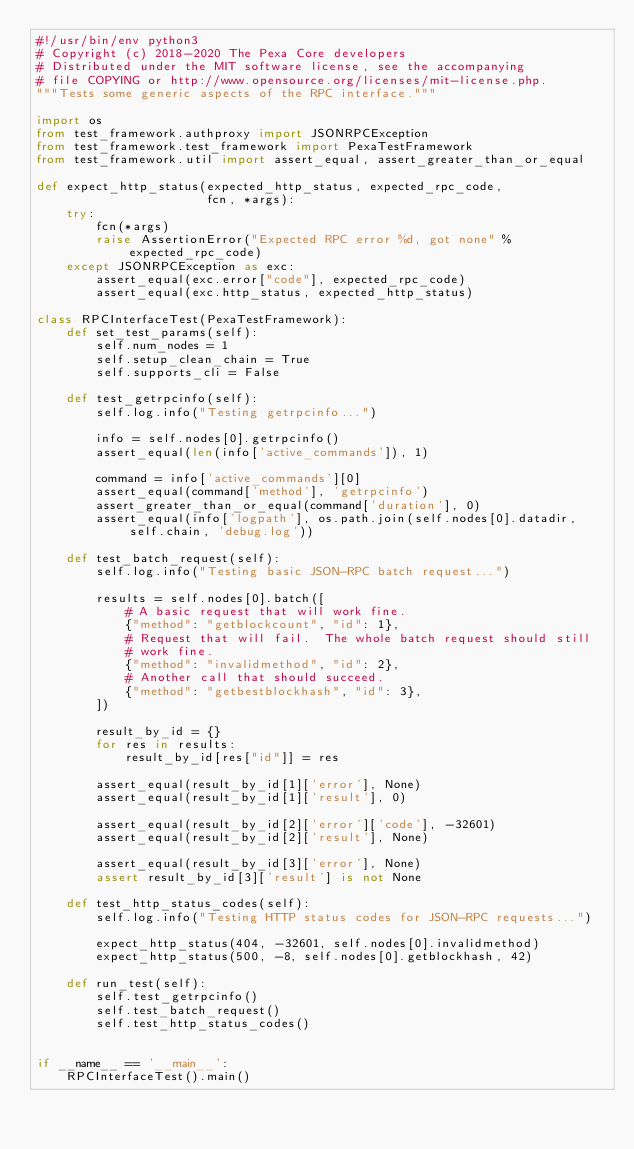<code> <loc_0><loc_0><loc_500><loc_500><_Python_>#!/usr/bin/env python3
# Copyright (c) 2018-2020 The Pexa Core developers
# Distributed under the MIT software license, see the accompanying
# file COPYING or http://www.opensource.org/licenses/mit-license.php.
"""Tests some generic aspects of the RPC interface."""

import os
from test_framework.authproxy import JSONRPCException
from test_framework.test_framework import PexaTestFramework
from test_framework.util import assert_equal, assert_greater_than_or_equal

def expect_http_status(expected_http_status, expected_rpc_code,
                       fcn, *args):
    try:
        fcn(*args)
        raise AssertionError("Expected RPC error %d, got none" % expected_rpc_code)
    except JSONRPCException as exc:
        assert_equal(exc.error["code"], expected_rpc_code)
        assert_equal(exc.http_status, expected_http_status)

class RPCInterfaceTest(PexaTestFramework):
    def set_test_params(self):
        self.num_nodes = 1
        self.setup_clean_chain = True
        self.supports_cli = False

    def test_getrpcinfo(self):
        self.log.info("Testing getrpcinfo...")

        info = self.nodes[0].getrpcinfo()
        assert_equal(len(info['active_commands']), 1)

        command = info['active_commands'][0]
        assert_equal(command['method'], 'getrpcinfo')
        assert_greater_than_or_equal(command['duration'], 0)
        assert_equal(info['logpath'], os.path.join(self.nodes[0].datadir, self.chain, 'debug.log'))

    def test_batch_request(self):
        self.log.info("Testing basic JSON-RPC batch request...")

        results = self.nodes[0].batch([
            # A basic request that will work fine.
            {"method": "getblockcount", "id": 1},
            # Request that will fail.  The whole batch request should still
            # work fine.
            {"method": "invalidmethod", "id": 2},
            # Another call that should succeed.
            {"method": "getbestblockhash", "id": 3},
        ])

        result_by_id = {}
        for res in results:
            result_by_id[res["id"]] = res

        assert_equal(result_by_id[1]['error'], None)
        assert_equal(result_by_id[1]['result'], 0)

        assert_equal(result_by_id[2]['error']['code'], -32601)
        assert_equal(result_by_id[2]['result'], None)

        assert_equal(result_by_id[3]['error'], None)
        assert result_by_id[3]['result'] is not None

    def test_http_status_codes(self):
        self.log.info("Testing HTTP status codes for JSON-RPC requests...")

        expect_http_status(404, -32601, self.nodes[0].invalidmethod)
        expect_http_status(500, -8, self.nodes[0].getblockhash, 42)

    def run_test(self):
        self.test_getrpcinfo()
        self.test_batch_request()
        self.test_http_status_codes()


if __name__ == '__main__':
    RPCInterfaceTest().main()
</code> 